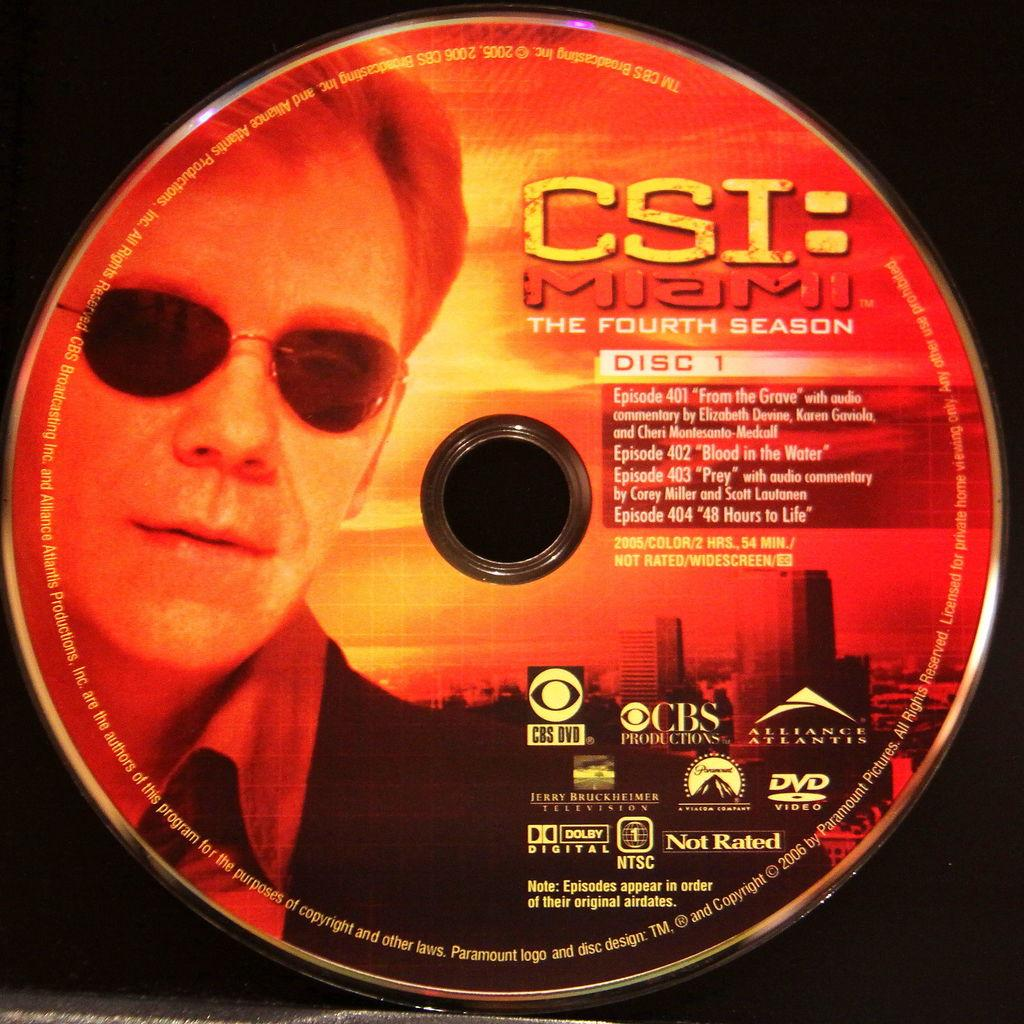What object is the main focus of the image? There is a CD in the image. What is depicted on the CD? There is a person's picture on the CD. What else is present on the CD besides the picture? There is text beside the picture on the CD, and there are logos on the CD. What type of paste is being used by the person in the image? There is no person or paste present in the image; it only features a CD with a picture, text, and logos. 